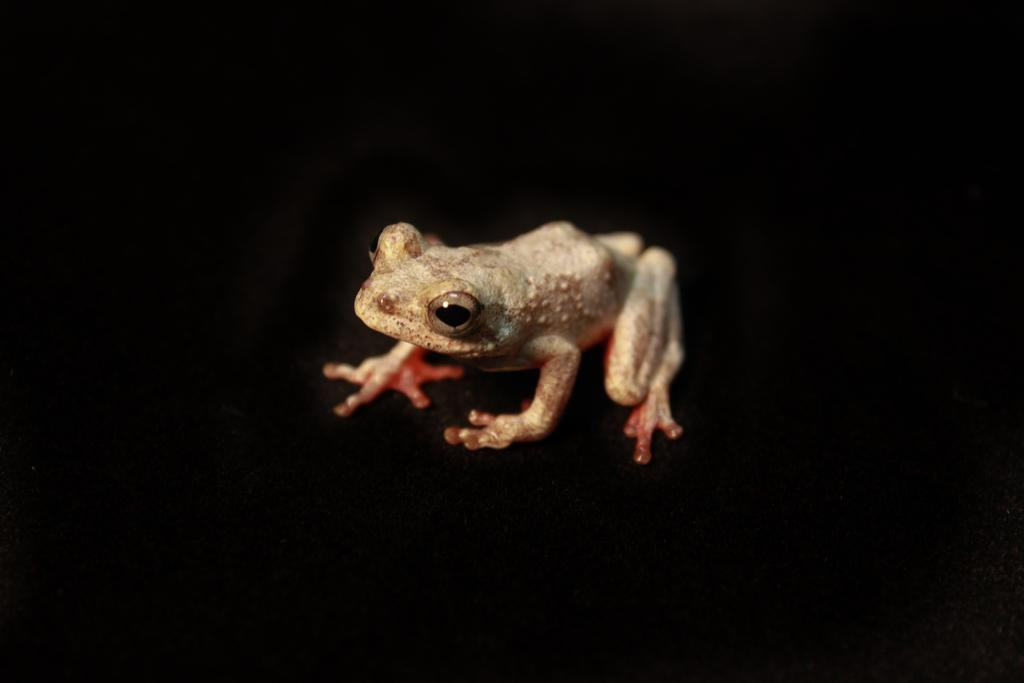What animal is present in the image? There is a frog in the image. What colors can be seen on the frog? The frog has orange, black, cream, and brown colors. What color is the background of the image? The background of the image is black. How many eggs does the frog have in the image? There are no eggs visible in the image; it features a frog with various colors. What type of eye is present on the frog in the image? The image does not show the frog's eye in detail, so it is not possible to determine the type of eye. 